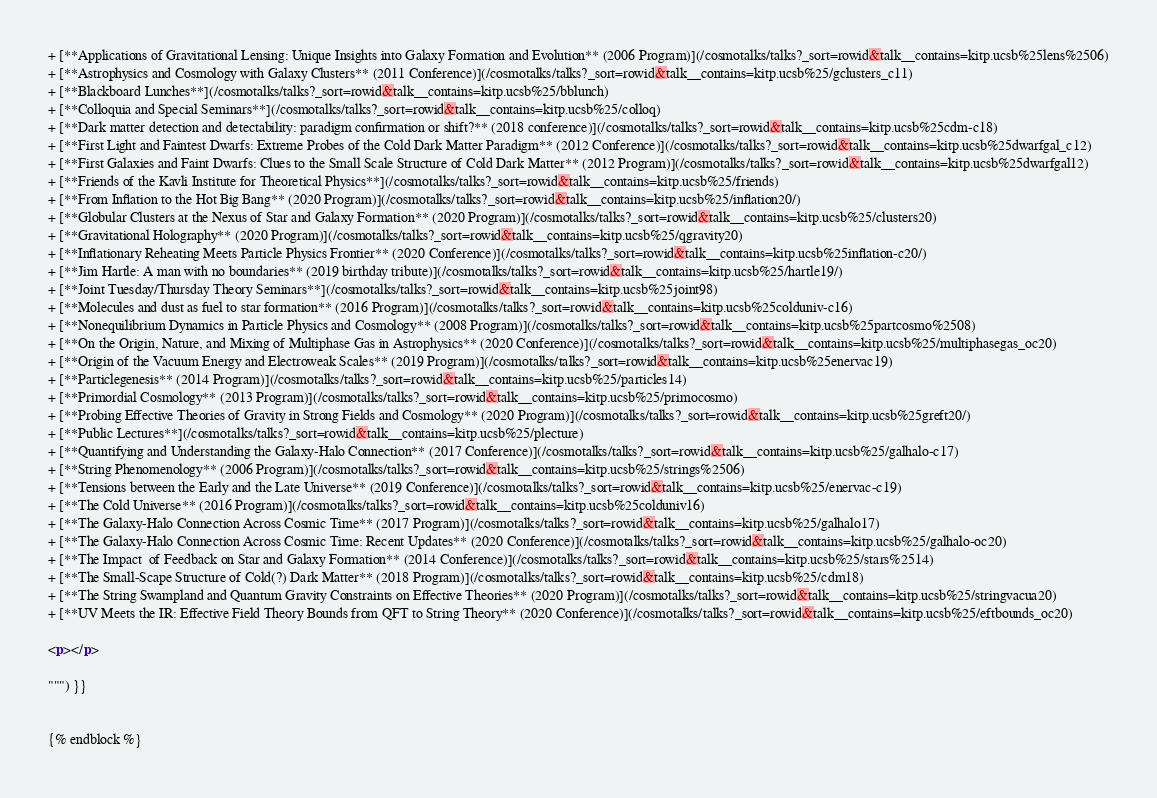<code> <loc_0><loc_0><loc_500><loc_500><_HTML_>+ [**Applications of Gravitational Lensing: Unique Insights into Galaxy Formation and Evolution** (2006 Program)](/cosmotalks/talks?_sort=rowid&talk__contains=kitp.ucsb%25lens%2506)
+ [**Astrophysics and Cosmology with Galaxy Clusters** (2011 Conference)](/cosmotalks/talks?_sort=rowid&talk__contains=kitp.ucsb%25/gclusters_c11)
+ [**Blackboard Lunches**](/cosmotalks/talks?_sort=rowid&talk__contains=kitp.ucsb%25/bblunch)
+ [**Colloquia and Special Seminars**](/cosmotalks/talks?_sort=rowid&talk__contains=kitp.ucsb%25/colloq)
+ [**Dark matter detection and detectability: paradigm confirmation or shift?** (2018 conference)](/cosmotalks/talks?_sort=rowid&talk__contains=kitp.ucsb%25cdm-c18)
+ [**First Light and Faintest Dwarfs: Extreme Probes of the Cold Dark Matter Paradigm** (2012 Conference)](/cosmotalks/talks?_sort=rowid&talk__contains=kitp.ucsb%25dwarfgal_c12)
+ [**First Galaxies and Faint Dwarfs: Clues to the Small Scale Structure of Cold Dark Matter** (2012 Program)](/cosmotalks/talks?_sort=rowid&talk__contains=kitp.ucsb%25dwarfgal12)
+ [**Friends of the Kavli Institute for Theoretical Physics**](/cosmotalks/talks?_sort=rowid&talk__contains=kitp.ucsb%25/friends)
+ [**From Inflation to the Hot Big Bang** (2020 Program)](/cosmotalks/talks?_sort=rowid&talk__contains=kitp.ucsb%25/inflation20/)
+ [**Globular Clusters at the Nexus of Star and Galaxy Formation** (2020 Program)](/cosmotalks/talks?_sort=rowid&talk__contains=kitp.ucsb%25/clusters20)
+ [**Gravitational Holography** (2020 Program)](/cosmotalks/talks?_sort=rowid&talk__contains=kitp.ucsb%25/qgravity20)
+ [**Inflationary Reheating Meets Particle Physics Frontier** (2020 Conference)](/cosmotalks/talks?_sort=rowid&talk__contains=kitp.ucsb%25inflation-c20/)
+ [**Jim Hartle: A man with no boundaries** (2019 birthday tribute)](/cosmotalks/talks?_sort=rowid&talk__contains=kitp.ucsb%25/hartle19/)
+ [**Joint Tuesday/Thursday Theory Seminars**](/cosmotalks/talks?_sort=rowid&talk__contains=kitp.ucsb%25joint98)
+ [**Molecules and dust as fuel to star formation** (2016 Program)](/cosmotalks/talks?_sort=rowid&talk__contains=kitp.ucsb%25colduniv-c16)
+ [**Nonequilibrium Dynamics in Particle Physics and Cosmology** (2008 Program)](/cosmotalks/talks?_sort=rowid&talk__contains=kitp.ucsb%25partcosmo%2508)
+ [**On the Origin, Nature, and Mixing of Multiphase Gas in Astrophysics** (2020 Conference)](/cosmotalks/talks?_sort=rowid&talk__contains=kitp.ucsb%25/multiphasegas_oc20)
+ [**Origin of the Vacuum Energy and Electroweak Scales** (2019 Program)](/cosmotalks/talks?_sort=rowid&talk__contains=kitp.ucsb%25enervac19)
+ [**Particlegenesis** (2014 Program)](/cosmotalks/talks?_sort=rowid&talk__contains=kitp.ucsb%25/particles14)
+ [**Primordial Cosmology** (2013 Program)](/cosmotalks/talks?_sort=rowid&talk__contains=kitp.ucsb%25/primocosmo)
+ [**Probing Effective Theories of Gravity in Strong Fields and Cosmology** (2020 Program)](/cosmotalks/talks?_sort=rowid&talk__contains=kitp.ucsb%25greft20/)
+ [**Public Lectures**](/cosmotalks/talks?_sort=rowid&talk__contains=kitp.ucsb%25/plecture)
+ [**Quantifying and Understanding the Galaxy-Halo Connection** (2017 Conference)](/cosmotalks/talks?_sort=rowid&talk__contains=kitp.ucsb%25/galhalo-c17)
+ [**String Phenomenology** (2006 Program)](/cosmotalks/talks?_sort=rowid&talk__contains=kitp.ucsb%25/strings%2506)
+ [**Tensions between the Early and the Late Universe** (2019 Conference)](/cosmotalks/talks?_sort=rowid&talk__contains=kitp.ucsb%25/enervac-c19)
+ [**The Cold Universe** (2016 Program)](/cosmotalks/talks?_sort=rowid&talk__contains=kitp.ucsb%25colduniv16)
+ [**The Galaxy-Halo Connection Across Cosmic Time** (2017 Program)](/cosmotalks/talks?_sort=rowid&talk__contains=kitp.ucsb%25/galhalo17)
+ [**The Galaxy-Halo Connection Across Cosmic Time: Recent Updates** (2020 Conference)](/cosmotalks/talks?_sort=rowid&talk__contains=kitp.ucsb%25/galhalo-oc20)
+ [**The Impact  of Feedback on Star and Galaxy Formation** (2014 Conference)](/cosmotalks/talks?_sort=rowid&talk__contains=kitp.ucsb%25/stars%2514)
+ [**The Small-Scape Structure of Cold(?) Dark Matter** (2018 Program)](/cosmotalks/talks?_sort=rowid&talk__contains=kitp.ucsb%25/cdm18)
+ [**The String Swampland and Quantum Gravity Constraints on Effective Theories** (2020 Program)](/cosmotalks/talks?_sort=rowid&talk__contains=kitp.ucsb%25/stringvacua20)
+ [**UV Meets the IR: Effective Field Theory Bounds from QFT to String Theory** (2020 Conference)](/cosmotalks/talks?_sort=rowid&talk__contains=kitp.ucsb%25/eftbounds_oc20)

<p></p> 

""") }}


{% endblock %}
</code> 